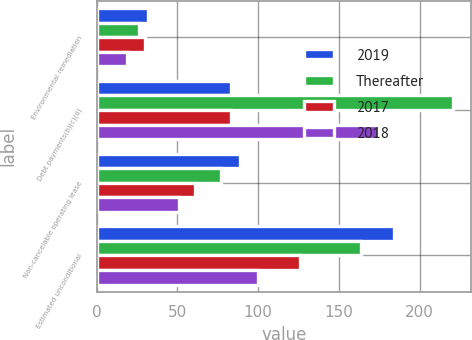Convert chart. <chart><loc_0><loc_0><loc_500><loc_500><stacked_bar_chart><ecel><fcel>Environmental remediation<fcel>Debt payments(b)(c)(d)<fcel>Non-cancelable operating lease<fcel>Estimated unconditional<nl><fcel>2019<fcel>32<fcel>83<fcel>89<fcel>184<nl><fcel>Thereafter<fcel>26<fcel>221<fcel>77<fcel>164<nl><fcel>2017<fcel>30<fcel>83<fcel>61<fcel>126<nl><fcel>2018<fcel>19<fcel>175<fcel>51<fcel>100<nl></chart> 